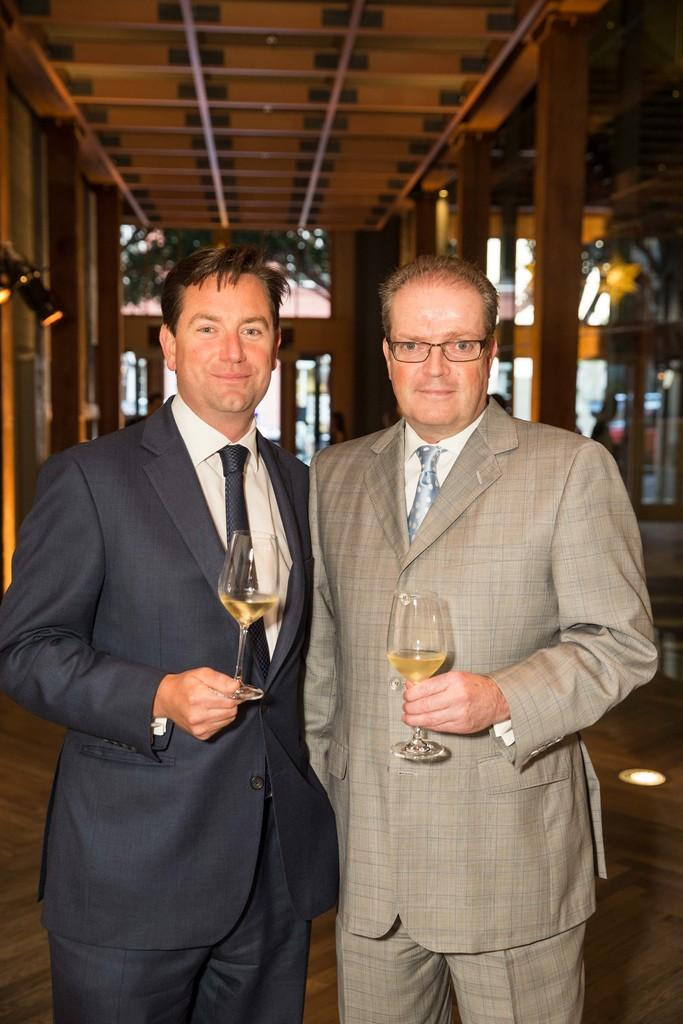How many people are in the image? There are two persons in the image. What are the persons doing in the image? The persons are standing and holding glasses. What can be seen in the background of the image? There are trees in the background of the image. What type of surface is visible in the image? The image shows a floor. What type of seed can be seen growing on the floor in the image? There is no seed growing on the floor in the image. What smell can be detected from the glasses in the image? The image does not provide any information about the smell of the glasses. 